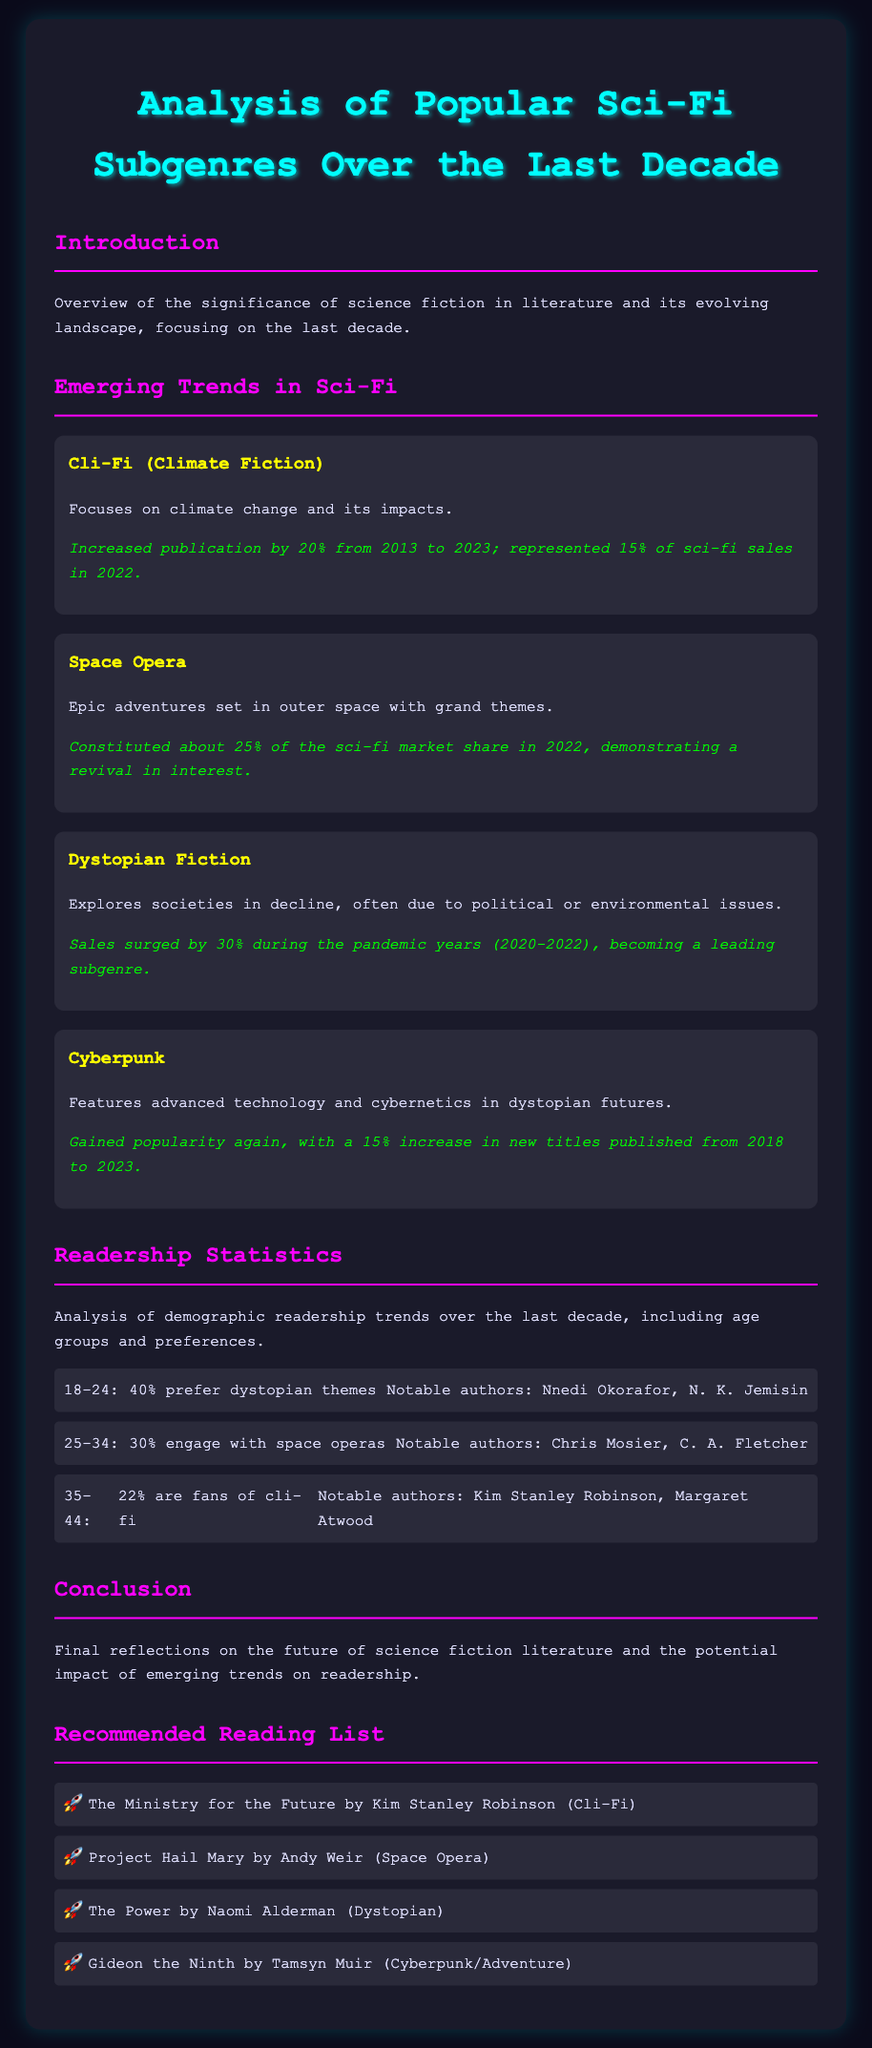What subgenre represents 15% of sci-fi sales in 2022? The document states that Cli-Fi represented 15% of sci-fi sales in 2022.
Answer: Cli-Fi What percentage of the sci-fi market share did Space Opera constitute in 2022? According to the document, Space Opera constituted about 25% of the sci-fi market share in 2022.
Answer: 25% Which subgenre saw sales surge by 30% during the pandemic years? The document indicates that Dystopian Fiction sales surged by 30% during the pandemic years (2020-2022).
Answer: Dystopian Fiction What notable authors are mentioned for the 18-24 age group? The document lists Nnedi Okorafor and N. K. Jemisin as notable authors for the 18-24 age group.
Answer: Nnedi Okorafor, N. K. Jemisin What is the primary focus of Cli-Fi? The document describes that Cli-Fi focuses on climate change and its impacts.
Answer: Climate change What percentage of the 35-44 age group are fans of Cli-Fi? The document states that 22% of the 35-44 age group are fans of Cli-Fi.
Answer: 22% Which subgenre gained a 15% increase in new titles published from 2018 to 2023? The document notes that Cyberpunk gained a 15% increase in new titles published from 2018 to 2023.
Answer: Cyberpunk Who authored "The Ministry for the Future"? The document indicates that Kim Stanley Robinson authored "The Ministry for the Future."
Answer: Kim Stanley Robinson How has the publication of Cli-Fi changed from 2013 to 2023? The document mentions that publication of Cli-Fi increased by 20% from 2013 to 2023.
Answer: Increased by 20% 